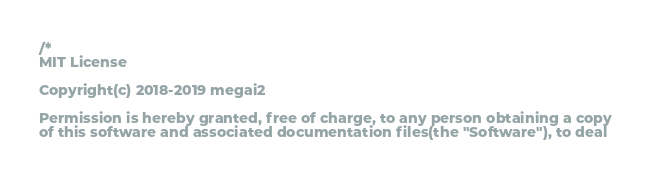<code> <loc_0><loc_0><loc_500><loc_500><_C++_>/*
MIT License

Copyright(c) 2018-2019 megai2

Permission is hereby granted, free of charge, to any person obtaining a copy
of this software and associated documentation files(the "Software"), to deal</code> 